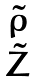Convert formula to latex. <formula><loc_0><loc_0><loc_500><loc_500>\begin{matrix} \tilde { \rho } \\ \tilde { Z } \end{matrix}</formula> 